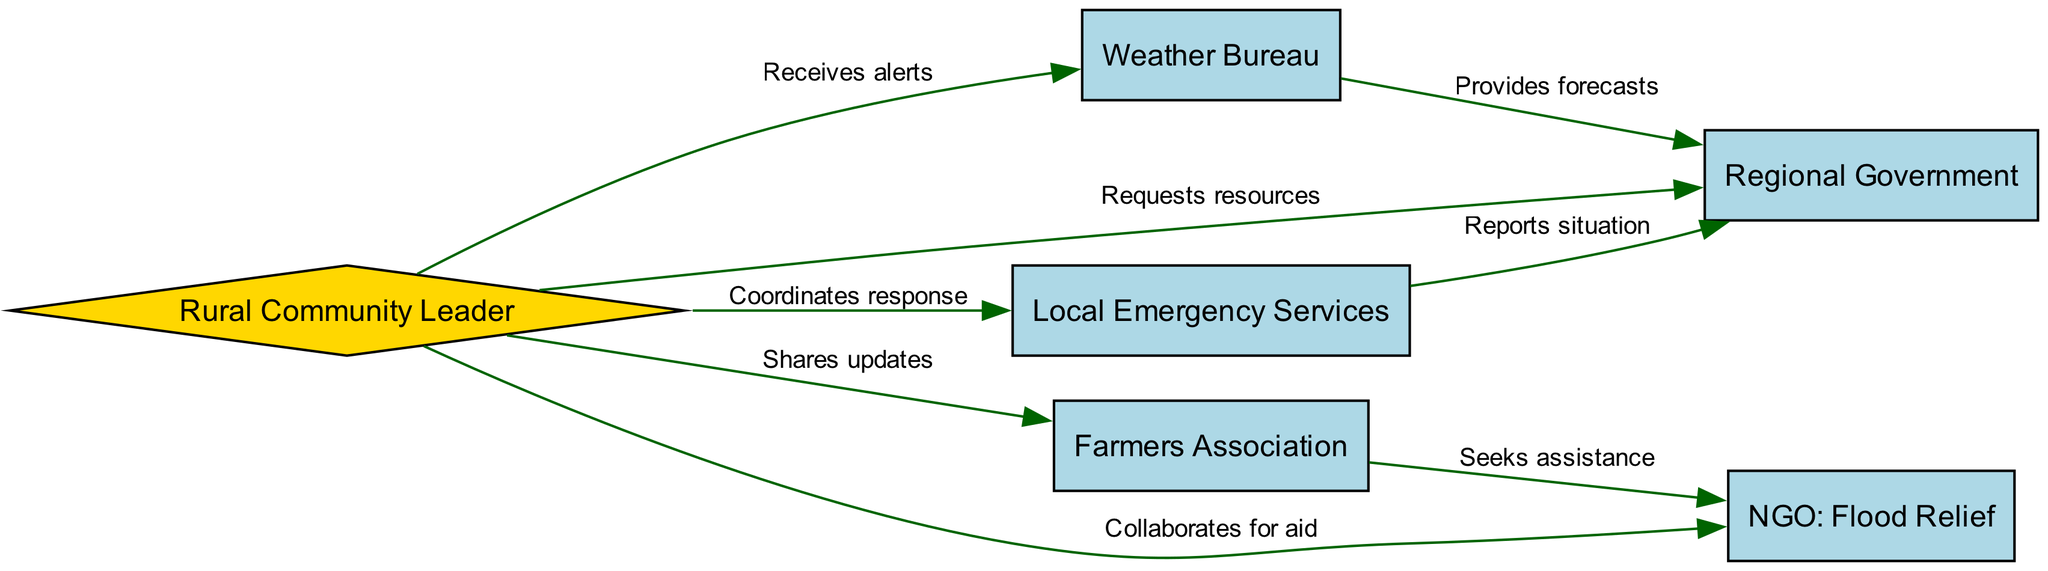What is the total number of nodes in the diagram? The diagram lists six distinct entities involved in flood management: Rural Community Leader, Local Emergency Services, Weather Bureau, Farmers Association, Regional Government, and NGO: Flood Relief. Counting these gives a total of six nodes.
Answer: 6 Which node represents the NGO involved in flood management? The node labeled "NGO: Flood Relief" identifies the organization focused on providing aid during floods. This label clearly indicates its function within the context of the diagram.
Answer: NGO: Flood Relief What relationship does the Rural Community Leader have with the Weather Bureau? The labeled edge between the Rural Community Leader and the Weather Bureau indicates that the Rural Community Leader "Receives alerts," representing a one-way flow of information concerning weather-related warnings and updates.
Answer: Receives alerts Which stakeholder connects Local Emergency Services and Regional Government? The edge labeled "Reports situation" originates from Local Emergency Services and connects to Regional Government, indicating that this service reports updates regarding the flood situation directly to the government body.
Answer: Reports situation How many edges are there in total in the diagram? The diagram displays a total of seven edges, each representing a specific relationship or flow of information between the different stakeholders involved in flood management. Counting all the labeled edges gives a total of seven.
Answer: 7 What kind of relationship exists between the Farmers Association and the NGO? The edge connecting Farmers Association to NGO: Flood Relief is labeled "Seeks assistance," which indicates that the Farmers Association reaches out to the NGO for support during flood situations, demonstrating a collaborative effort.
Answer: Seeks assistance Who does the Rural Community Leader collaborate with for aid? The diagram specifies that the Rural Community Leader collaborates with the NGO labeled "Flood Relief" to coordinate support and resources aimed at assisting the community during floods.
Answer: NGO: Flood Relief Which stakeholders provide forecasts to the Regional Government? The Weather Bureau provides forecasts to the Regional Government, as depicted by the edge labeled "Provides forecasts." This relationship highlights the Weather Bureau's role in supplying critical weather information to help the government prepare for floods.
Answer: Weather Bureau 